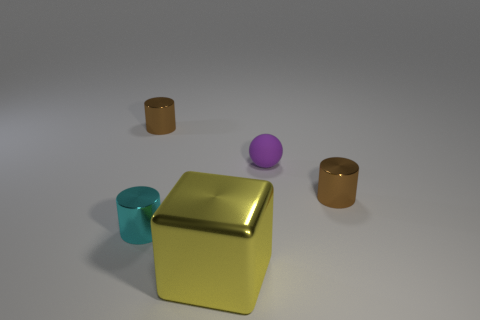Are there any brown objects that have the same shape as the cyan thing?
Provide a succinct answer. Yes. There is a metal object that is both behind the cube and on the right side of the tiny cyan shiny cylinder; what color is it?
Offer a terse response. Brown. How many large things are either balls or cyan metallic cylinders?
Offer a very short reply. 0. Is there anything else of the same color as the tiny rubber object?
Your answer should be compact. No. There is another cyan object that is made of the same material as the large thing; what is its shape?
Make the answer very short. Cylinder. There is a brown metal cylinder that is to the left of the large thing; what size is it?
Make the answer very short. Small. The purple object is what shape?
Your answer should be compact. Sphere. Do the brown metal thing that is on the right side of the large yellow metal cube and the yellow shiny object that is to the left of the tiny purple thing have the same size?
Ensure brevity in your answer.  No. How big is the brown object that is in front of the tiny thing that is behind the purple ball behind the cyan thing?
Provide a short and direct response. Small. The small brown thing that is in front of the metallic object that is behind the metallic thing that is to the right of the big object is what shape?
Provide a short and direct response. Cylinder. 